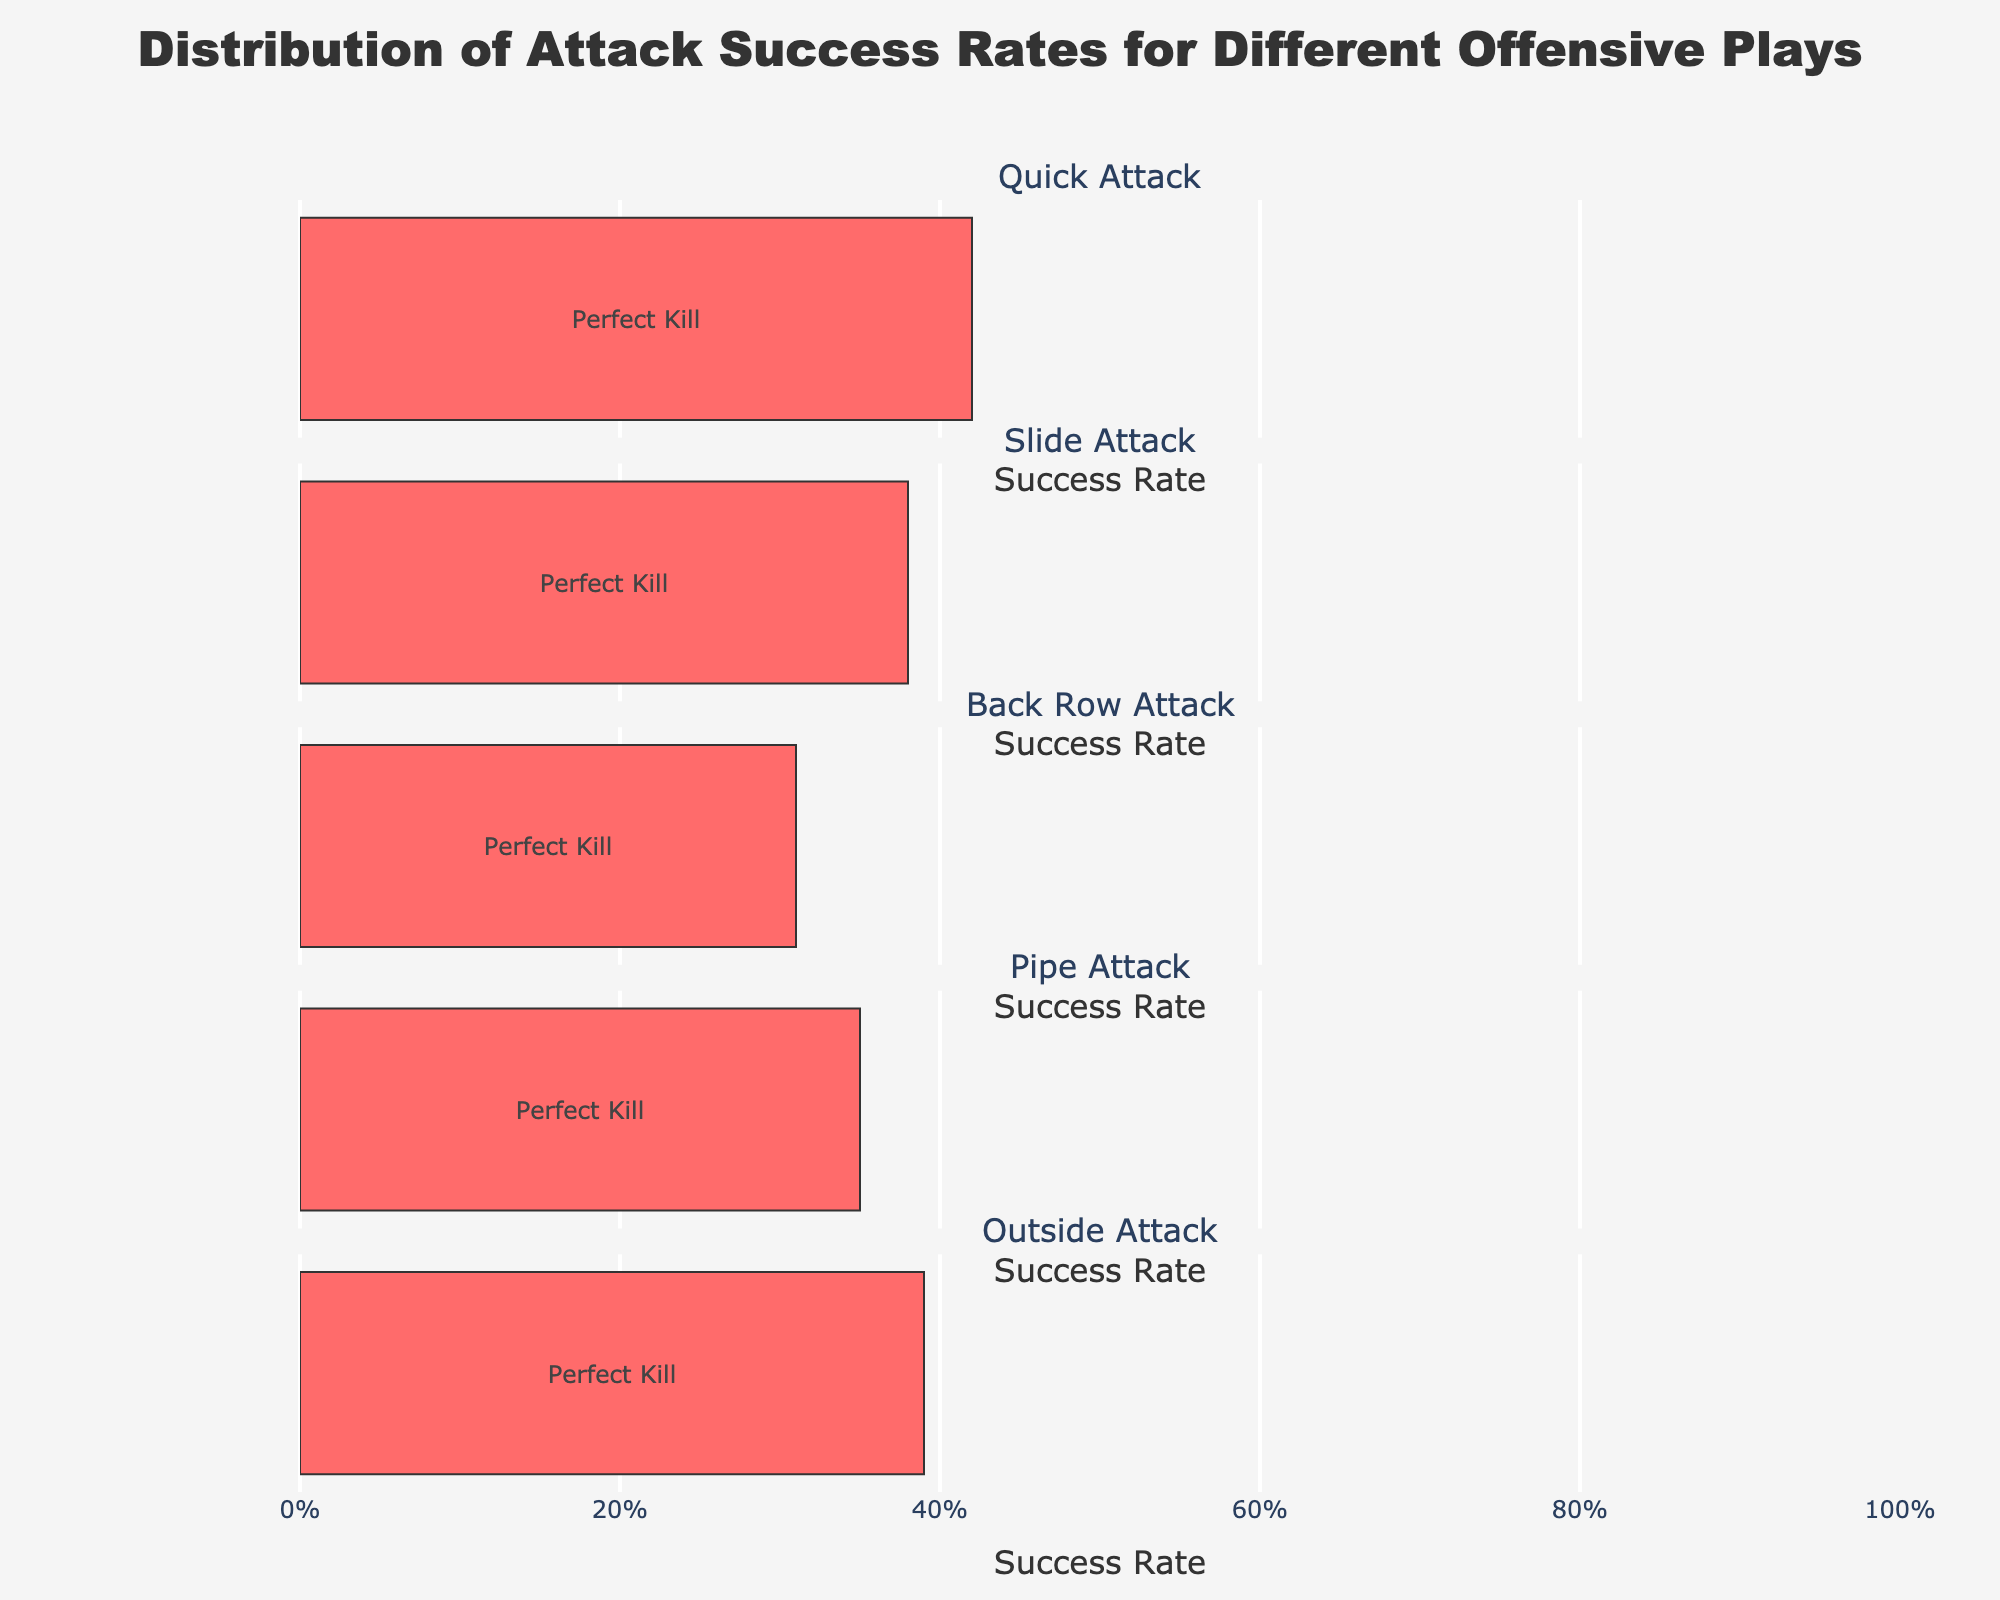What is the title of the figure? The title of the figure is located at the top center and reads "Church Activities: Noise Levels and Impact".
Answer: Church Activities: Noise Levels and Impact What activity has the highest decibel level? The decibel level bar at 90 is labeled with the activity "Christmas Midnight Mass".
Answer: Christmas Midnight Mass Which time slot has both minimal decibel levels and a "Barely Audible" impact? The Evening Mass has a decibel level of 55 and shows minimal impact, while Choir Practice has a decibel level of 50 and is labeled "Barely Audible". Both of these fit the criteria.
Answer: Choir Practice How many activities have a decibel level above 80? Reviewing the decibel levels, there are three activities above 80: Sunday Mass (80), Easter Vigil (85), and Christmas Midnight Mass (90).
Answer: 3 What is the impact level of the activity at 3:00 PM? Referencing the impact markers for 3:00 PM, School Dismissal has an impact labeled "Moderate".
Answer: Moderate Which activity between 6:00 AM and 10:00 AM has the lowest decibel level? The activities between 6:00 AM and 10:00 AM are Morning Bell (75), Weekday Mass (60), and the Sunday Morning (10:00 AM), where Weekday Mass has the lowest decibel level at 60.
Answer: Weekday Mass What is the impact level of the activity with a decibel level of 70? There are two activities with a decibel level of 70: Angelus Bell and Baptism Ceremony. Both these activities are labeled with the impact "Noticeable".
Answer: Noticeable Which activity is indicated as a "Major Disturbance" and what is its time? Looking at the impact markers for "Major Disturbance", it corresponds to the Easter Vigil activity, which occurs at 20:00.
Answer: Easter Vigil, 20:00 Compare the decibel level of Wedding Ceremony to that of School Dismissal. The decibel level of Wedding Ceremony is 75, while that of School Dismissal is 65. The Wedding Ceremony has a higher decibel level by 10 units.
Answer: Wedding Ceremony is 10 units higher What time of day does the activity with the negligible impact occur? The negligible impact marker corresponds to Night Prayer, which occurs at 22:00.
Answer: 22:00 